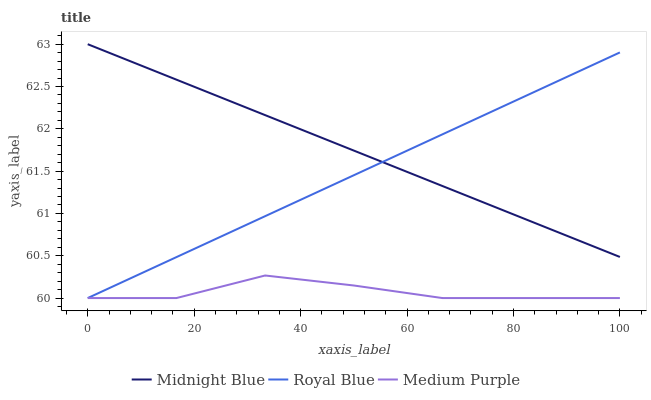Does Medium Purple have the minimum area under the curve?
Answer yes or no. Yes. Does Midnight Blue have the maximum area under the curve?
Answer yes or no. Yes. Does Royal Blue have the minimum area under the curve?
Answer yes or no. No. Does Royal Blue have the maximum area under the curve?
Answer yes or no. No. Is Midnight Blue the smoothest?
Answer yes or no. Yes. Is Medium Purple the roughest?
Answer yes or no. Yes. Is Royal Blue the smoothest?
Answer yes or no. No. Is Royal Blue the roughest?
Answer yes or no. No. Does Medium Purple have the lowest value?
Answer yes or no. Yes. Does Midnight Blue have the lowest value?
Answer yes or no. No. Does Midnight Blue have the highest value?
Answer yes or no. Yes. Does Royal Blue have the highest value?
Answer yes or no. No. Is Medium Purple less than Midnight Blue?
Answer yes or no. Yes. Is Midnight Blue greater than Medium Purple?
Answer yes or no. Yes. Does Royal Blue intersect Midnight Blue?
Answer yes or no. Yes. Is Royal Blue less than Midnight Blue?
Answer yes or no. No. Is Royal Blue greater than Midnight Blue?
Answer yes or no. No. Does Medium Purple intersect Midnight Blue?
Answer yes or no. No. 